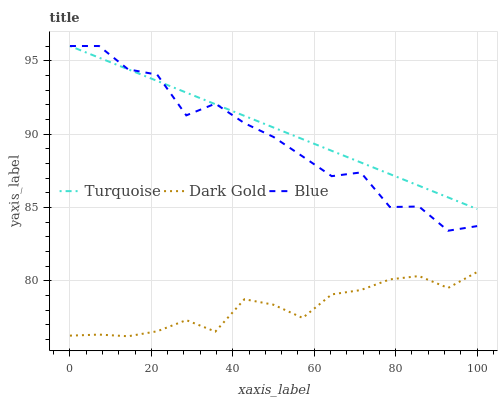Does Dark Gold have the minimum area under the curve?
Answer yes or no. Yes. Does Turquoise have the maximum area under the curve?
Answer yes or no. Yes. Does Turquoise have the minimum area under the curve?
Answer yes or no. No. Does Dark Gold have the maximum area under the curve?
Answer yes or no. No. Is Turquoise the smoothest?
Answer yes or no. Yes. Is Blue the roughest?
Answer yes or no. Yes. Is Dark Gold the smoothest?
Answer yes or no. No. Is Dark Gold the roughest?
Answer yes or no. No. Does Dark Gold have the lowest value?
Answer yes or no. Yes. Does Turquoise have the lowest value?
Answer yes or no. No. Does Turquoise have the highest value?
Answer yes or no. Yes. Does Dark Gold have the highest value?
Answer yes or no. No. Is Dark Gold less than Blue?
Answer yes or no. Yes. Is Blue greater than Dark Gold?
Answer yes or no. Yes. Does Blue intersect Turquoise?
Answer yes or no. Yes. Is Blue less than Turquoise?
Answer yes or no. No. Is Blue greater than Turquoise?
Answer yes or no. No. Does Dark Gold intersect Blue?
Answer yes or no. No. 